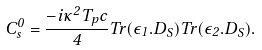<formula> <loc_0><loc_0><loc_500><loc_500>C _ { s } ^ { 0 } = { \frac { - i \kappa ^ { 2 } T _ { p } c } { 4 } } T r ( \epsilon _ { 1 } . D _ { S } ) T r ( \epsilon _ { 2 } . D _ { S } ) .</formula> 